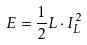<formula> <loc_0><loc_0><loc_500><loc_500>E = \frac { 1 } { 2 } L \cdot I _ { L } ^ { 2 }</formula> 